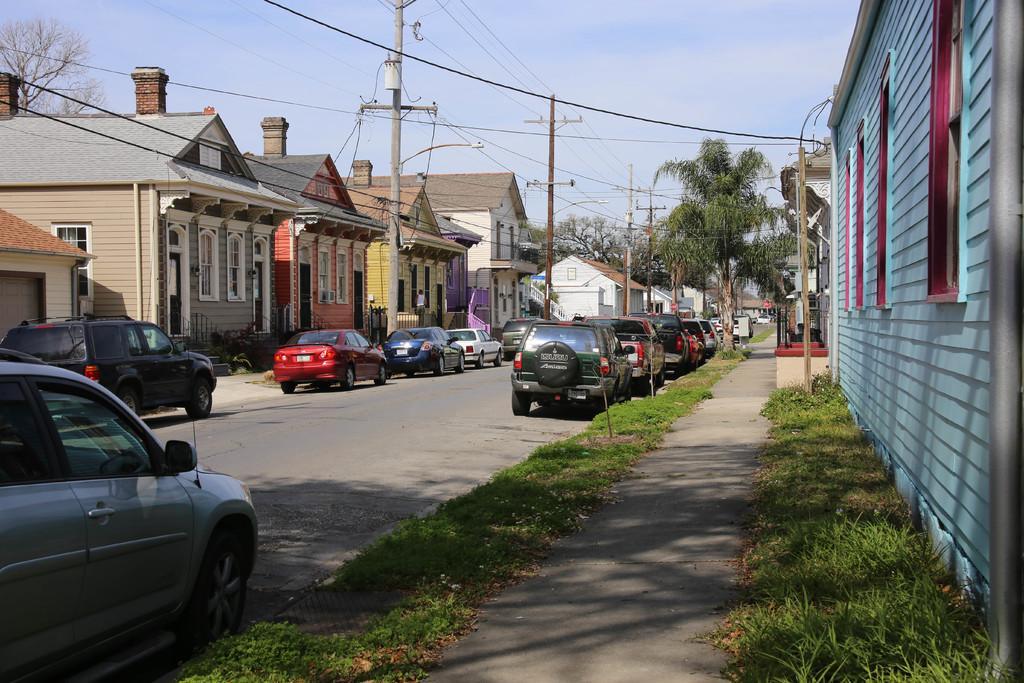How would you summarize this image in a sentence or two? As we can see in the image there are cars, grass, current polls houses, trees and sky. 